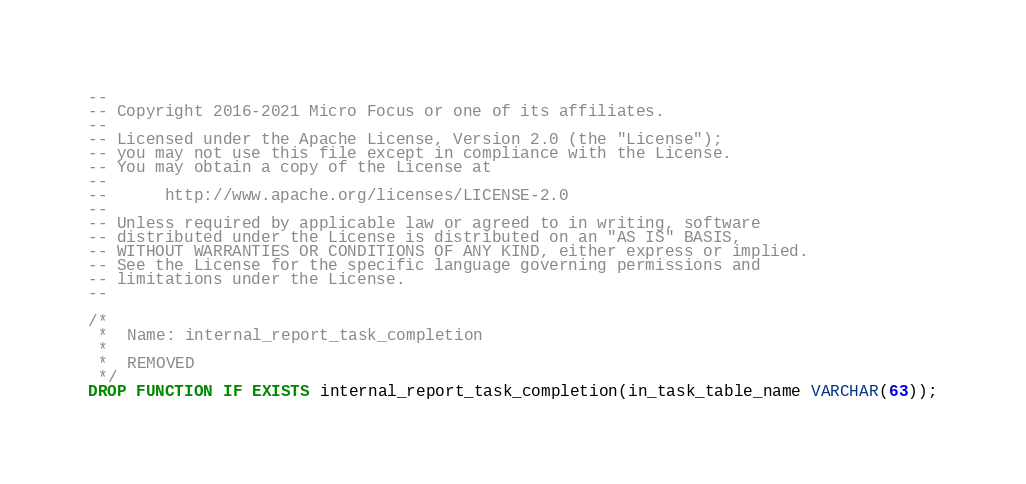<code> <loc_0><loc_0><loc_500><loc_500><_SQL_>--
-- Copyright 2016-2021 Micro Focus or one of its affiliates.
--
-- Licensed under the Apache License, Version 2.0 (the "License");
-- you may not use this file except in compliance with the License.
-- You may obtain a copy of the License at
--
--      http://www.apache.org/licenses/LICENSE-2.0
--
-- Unless required by applicable law or agreed to in writing, software
-- distributed under the License is distributed on an "AS IS" BASIS,
-- WITHOUT WARRANTIES OR CONDITIONS OF ANY KIND, either express or implied.
-- See the License for the specific language governing permissions and
-- limitations under the License.
--

/*
 *  Name: internal_report_task_completion
 *
 *  REMOVED
 */
DROP FUNCTION IF EXISTS internal_report_task_completion(in_task_table_name VARCHAR(63));
</code> 